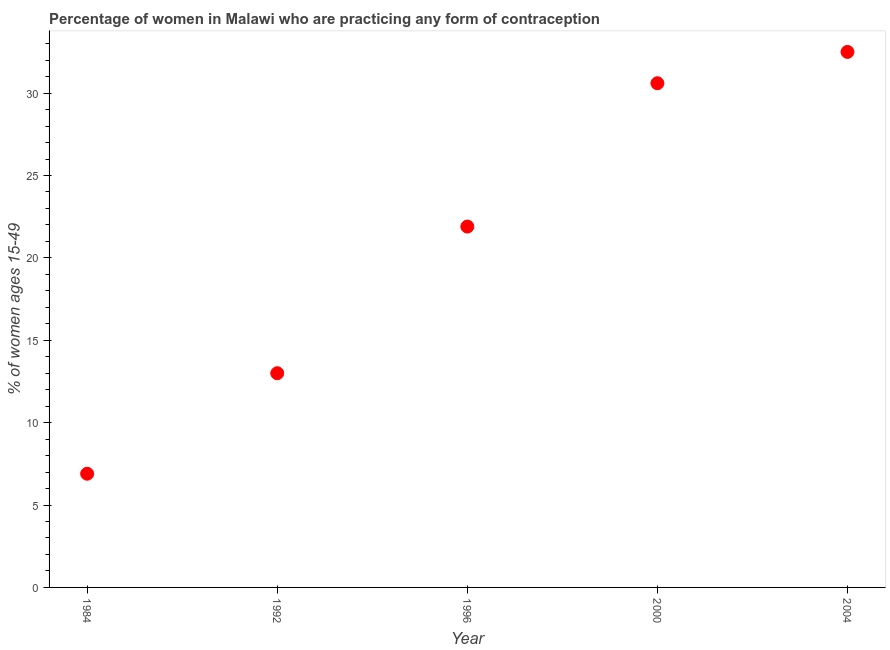Across all years, what is the maximum contraceptive prevalence?
Offer a terse response. 32.5. Across all years, what is the minimum contraceptive prevalence?
Give a very brief answer. 6.9. In which year was the contraceptive prevalence maximum?
Give a very brief answer. 2004. What is the sum of the contraceptive prevalence?
Your response must be concise. 104.9. What is the difference between the contraceptive prevalence in 1996 and 2000?
Ensure brevity in your answer.  -8.7. What is the average contraceptive prevalence per year?
Offer a terse response. 20.98. What is the median contraceptive prevalence?
Your response must be concise. 21.9. What is the ratio of the contraceptive prevalence in 1996 to that in 2004?
Your answer should be compact. 0.67. Is the contraceptive prevalence in 1996 less than that in 2000?
Your answer should be very brief. Yes. Is the difference between the contraceptive prevalence in 1984 and 2000 greater than the difference between any two years?
Make the answer very short. No. What is the difference between the highest and the second highest contraceptive prevalence?
Make the answer very short. 1.9. What is the difference between the highest and the lowest contraceptive prevalence?
Your response must be concise. 25.6. In how many years, is the contraceptive prevalence greater than the average contraceptive prevalence taken over all years?
Offer a very short reply. 3. Does the contraceptive prevalence monotonically increase over the years?
Offer a terse response. Yes. How many years are there in the graph?
Give a very brief answer. 5. What is the difference between two consecutive major ticks on the Y-axis?
Provide a short and direct response. 5. Does the graph contain any zero values?
Offer a terse response. No. What is the title of the graph?
Give a very brief answer. Percentage of women in Malawi who are practicing any form of contraception. What is the label or title of the Y-axis?
Provide a short and direct response. % of women ages 15-49. What is the % of women ages 15-49 in 1984?
Offer a terse response. 6.9. What is the % of women ages 15-49 in 1992?
Provide a short and direct response. 13. What is the % of women ages 15-49 in 1996?
Give a very brief answer. 21.9. What is the % of women ages 15-49 in 2000?
Your response must be concise. 30.6. What is the % of women ages 15-49 in 2004?
Your answer should be compact. 32.5. What is the difference between the % of women ages 15-49 in 1984 and 2000?
Offer a very short reply. -23.7. What is the difference between the % of women ages 15-49 in 1984 and 2004?
Ensure brevity in your answer.  -25.6. What is the difference between the % of women ages 15-49 in 1992 and 2000?
Provide a short and direct response. -17.6. What is the difference between the % of women ages 15-49 in 1992 and 2004?
Your response must be concise. -19.5. What is the difference between the % of women ages 15-49 in 1996 and 2000?
Make the answer very short. -8.7. What is the difference between the % of women ages 15-49 in 2000 and 2004?
Offer a very short reply. -1.9. What is the ratio of the % of women ages 15-49 in 1984 to that in 1992?
Your response must be concise. 0.53. What is the ratio of the % of women ages 15-49 in 1984 to that in 1996?
Make the answer very short. 0.32. What is the ratio of the % of women ages 15-49 in 1984 to that in 2000?
Ensure brevity in your answer.  0.23. What is the ratio of the % of women ages 15-49 in 1984 to that in 2004?
Your answer should be very brief. 0.21. What is the ratio of the % of women ages 15-49 in 1992 to that in 1996?
Provide a short and direct response. 0.59. What is the ratio of the % of women ages 15-49 in 1992 to that in 2000?
Ensure brevity in your answer.  0.42. What is the ratio of the % of women ages 15-49 in 1992 to that in 2004?
Offer a very short reply. 0.4. What is the ratio of the % of women ages 15-49 in 1996 to that in 2000?
Ensure brevity in your answer.  0.72. What is the ratio of the % of women ages 15-49 in 1996 to that in 2004?
Offer a very short reply. 0.67. What is the ratio of the % of women ages 15-49 in 2000 to that in 2004?
Keep it short and to the point. 0.94. 